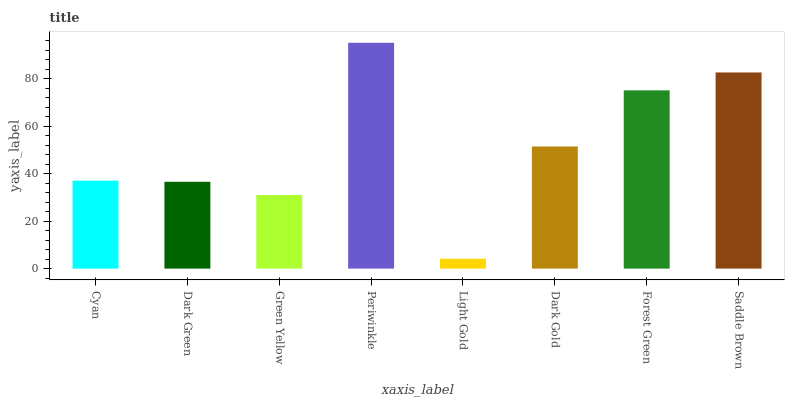Is Dark Green the minimum?
Answer yes or no. No. Is Dark Green the maximum?
Answer yes or no. No. Is Cyan greater than Dark Green?
Answer yes or no. Yes. Is Dark Green less than Cyan?
Answer yes or no. Yes. Is Dark Green greater than Cyan?
Answer yes or no. No. Is Cyan less than Dark Green?
Answer yes or no. No. Is Dark Gold the high median?
Answer yes or no. Yes. Is Cyan the low median?
Answer yes or no. Yes. Is Dark Green the high median?
Answer yes or no. No. Is Dark Green the low median?
Answer yes or no. No. 